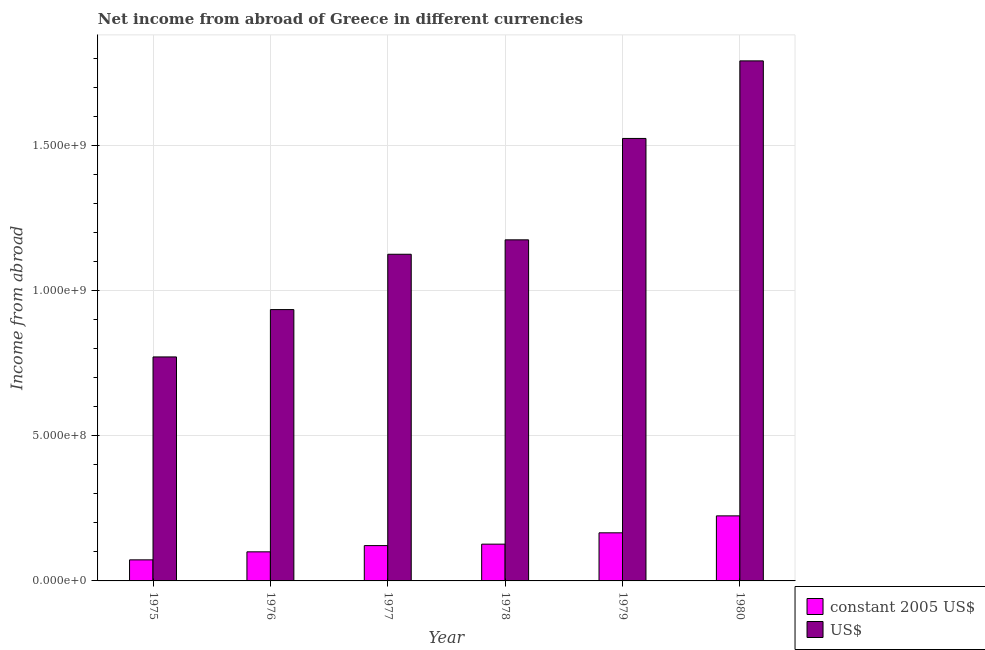Are the number of bars per tick equal to the number of legend labels?
Offer a terse response. Yes. Are the number of bars on each tick of the X-axis equal?
Your answer should be compact. Yes. In how many cases, is the number of bars for a given year not equal to the number of legend labels?
Give a very brief answer. 0. What is the income from abroad in constant 2005 us$ in 1975?
Offer a terse response. 7.26e+07. Across all years, what is the maximum income from abroad in us$?
Provide a short and direct response. 1.79e+09. Across all years, what is the minimum income from abroad in us$?
Your response must be concise. 7.72e+08. In which year was the income from abroad in constant 2005 us$ maximum?
Your response must be concise. 1980. In which year was the income from abroad in us$ minimum?
Ensure brevity in your answer.  1975. What is the total income from abroad in us$ in the graph?
Ensure brevity in your answer.  7.33e+09. What is the difference between the income from abroad in us$ in 1975 and that in 1976?
Offer a very short reply. -1.63e+08. What is the difference between the income from abroad in us$ in 1979 and the income from abroad in constant 2005 us$ in 1980?
Provide a succinct answer. -2.67e+08. What is the average income from abroad in constant 2005 us$ per year?
Provide a succinct answer. 1.35e+08. In the year 1979, what is the difference between the income from abroad in us$ and income from abroad in constant 2005 us$?
Provide a short and direct response. 0. In how many years, is the income from abroad in us$ greater than 400000000 units?
Offer a terse response. 6. What is the ratio of the income from abroad in us$ in 1975 to that in 1977?
Provide a succinct answer. 0.69. Is the income from abroad in us$ in 1977 less than that in 1979?
Your response must be concise. Yes. Is the difference between the income from abroad in us$ in 1976 and 1978 greater than the difference between the income from abroad in constant 2005 us$ in 1976 and 1978?
Provide a succinct answer. No. What is the difference between the highest and the second highest income from abroad in constant 2005 us$?
Your answer should be very brief. 5.84e+07. What is the difference between the highest and the lowest income from abroad in us$?
Offer a terse response. 1.02e+09. Is the sum of the income from abroad in constant 2005 us$ in 1975 and 1980 greater than the maximum income from abroad in us$ across all years?
Provide a short and direct response. Yes. What does the 2nd bar from the left in 1978 represents?
Offer a very short reply. US$. What does the 1st bar from the right in 1976 represents?
Your response must be concise. US$. How many bars are there?
Provide a succinct answer. 12. Are all the bars in the graph horizontal?
Make the answer very short. No. How many years are there in the graph?
Offer a very short reply. 6. What is the difference between two consecutive major ticks on the Y-axis?
Keep it short and to the point. 5.00e+08. Does the graph contain grids?
Provide a short and direct response. Yes. How many legend labels are there?
Keep it short and to the point. 2. What is the title of the graph?
Offer a terse response. Net income from abroad of Greece in different currencies. Does "Non-resident workers" appear as one of the legend labels in the graph?
Your response must be concise. No. What is the label or title of the Y-axis?
Offer a terse response. Income from abroad. What is the Income from abroad of constant 2005 US$ in 1975?
Your answer should be very brief. 7.26e+07. What is the Income from abroad of US$ in 1975?
Provide a succinct answer. 7.72e+08. What is the Income from abroad in constant 2005 US$ in 1976?
Your answer should be very brief. 1.00e+08. What is the Income from abroad of US$ in 1976?
Keep it short and to the point. 9.35e+08. What is the Income from abroad in constant 2005 US$ in 1977?
Give a very brief answer. 1.22e+08. What is the Income from abroad of US$ in 1977?
Provide a succinct answer. 1.13e+09. What is the Income from abroad of constant 2005 US$ in 1978?
Give a very brief answer. 1.27e+08. What is the Income from abroad in US$ in 1978?
Ensure brevity in your answer.  1.18e+09. What is the Income from abroad of constant 2005 US$ in 1979?
Make the answer very short. 1.66e+08. What is the Income from abroad in US$ in 1979?
Give a very brief answer. 1.52e+09. What is the Income from abroad in constant 2005 US$ in 1980?
Your answer should be very brief. 2.24e+08. What is the Income from abroad in US$ in 1980?
Offer a very short reply. 1.79e+09. Across all years, what is the maximum Income from abroad of constant 2005 US$?
Offer a very short reply. 2.24e+08. Across all years, what is the maximum Income from abroad in US$?
Your answer should be very brief. 1.79e+09. Across all years, what is the minimum Income from abroad of constant 2005 US$?
Provide a succinct answer. 7.26e+07. Across all years, what is the minimum Income from abroad of US$?
Provide a succinct answer. 7.72e+08. What is the total Income from abroad of constant 2005 US$ in the graph?
Offer a very short reply. 8.11e+08. What is the total Income from abroad of US$ in the graph?
Make the answer very short. 7.33e+09. What is the difference between the Income from abroad in constant 2005 US$ in 1975 and that in 1976?
Your answer should be very brief. -2.76e+07. What is the difference between the Income from abroad in US$ in 1975 and that in 1976?
Your answer should be compact. -1.63e+08. What is the difference between the Income from abroad in constant 2005 US$ in 1975 and that in 1977?
Your response must be concise. -4.91e+07. What is the difference between the Income from abroad in US$ in 1975 and that in 1977?
Offer a terse response. -3.54e+08. What is the difference between the Income from abroad in constant 2005 US$ in 1975 and that in 1978?
Provide a succinct answer. -5.41e+07. What is the difference between the Income from abroad of US$ in 1975 and that in 1978?
Provide a short and direct response. -4.04e+08. What is the difference between the Income from abroad of constant 2005 US$ in 1975 and that in 1979?
Provide a succinct answer. -9.31e+07. What is the difference between the Income from abroad in US$ in 1975 and that in 1979?
Make the answer very short. -7.53e+08. What is the difference between the Income from abroad in constant 2005 US$ in 1975 and that in 1980?
Offer a very short reply. -1.52e+08. What is the difference between the Income from abroad of US$ in 1975 and that in 1980?
Offer a very short reply. -1.02e+09. What is the difference between the Income from abroad of constant 2005 US$ in 1976 and that in 1977?
Keep it short and to the point. -2.15e+07. What is the difference between the Income from abroad of US$ in 1976 and that in 1977?
Offer a terse response. -1.91e+08. What is the difference between the Income from abroad in constant 2005 US$ in 1976 and that in 1978?
Provide a short and direct response. -2.65e+07. What is the difference between the Income from abroad in US$ in 1976 and that in 1978?
Provide a succinct answer. -2.40e+08. What is the difference between the Income from abroad in constant 2005 US$ in 1976 and that in 1979?
Provide a succinct answer. -6.55e+07. What is the difference between the Income from abroad in US$ in 1976 and that in 1979?
Provide a short and direct response. -5.90e+08. What is the difference between the Income from abroad in constant 2005 US$ in 1976 and that in 1980?
Make the answer very short. -1.24e+08. What is the difference between the Income from abroad of US$ in 1976 and that in 1980?
Your answer should be very brief. -8.57e+08. What is the difference between the Income from abroad of constant 2005 US$ in 1977 and that in 1978?
Your answer should be compact. -5.02e+06. What is the difference between the Income from abroad of US$ in 1977 and that in 1978?
Your answer should be compact. -4.97e+07. What is the difference between the Income from abroad in constant 2005 US$ in 1977 and that in 1979?
Offer a very short reply. -4.41e+07. What is the difference between the Income from abroad of US$ in 1977 and that in 1979?
Provide a short and direct response. -3.99e+08. What is the difference between the Income from abroad in constant 2005 US$ in 1977 and that in 1980?
Ensure brevity in your answer.  -1.03e+08. What is the difference between the Income from abroad of US$ in 1977 and that in 1980?
Your answer should be compact. -6.66e+08. What is the difference between the Income from abroad in constant 2005 US$ in 1978 and that in 1979?
Keep it short and to the point. -3.90e+07. What is the difference between the Income from abroad of US$ in 1978 and that in 1979?
Give a very brief answer. -3.49e+08. What is the difference between the Income from abroad of constant 2005 US$ in 1978 and that in 1980?
Provide a succinct answer. -9.75e+07. What is the difference between the Income from abroad of US$ in 1978 and that in 1980?
Keep it short and to the point. -6.17e+08. What is the difference between the Income from abroad in constant 2005 US$ in 1979 and that in 1980?
Your answer should be compact. -5.84e+07. What is the difference between the Income from abroad of US$ in 1979 and that in 1980?
Offer a very short reply. -2.67e+08. What is the difference between the Income from abroad in constant 2005 US$ in 1975 and the Income from abroad in US$ in 1976?
Give a very brief answer. -8.62e+08. What is the difference between the Income from abroad of constant 2005 US$ in 1975 and the Income from abroad of US$ in 1977?
Provide a short and direct response. -1.05e+09. What is the difference between the Income from abroad in constant 2005 US$ in 1975 and the Income from abroad in US$ in 1978?
Your response must be concise. -1.10e+09. What is the difference between the Income from abroad of constant 2005 US$ in 1975 and the Income from abroad of US$ in 1979?
Ensure brevity in your answer.  -1.45e+09. What is the difference between the Income from abroad of constant 2005 US$ in 1975 and the Income from abroad of US$ in 1980?
Provide a succinct answer. -1.72e+09. What is the difference between the Income from abroad of constant 2005 US$ in 1976 and the Income from abroad of US$ in 1977?
Your answer should be compact. -1.03e+09. What is the difference between the Income from abroad of constant 2005 US$ in 1976 and the Income from abroad of US$ in 1978?
Your answer should be very brief. -1.08e+09. What is the difference between the Income from abroad in constant 2005 US$ in 1976 and the Income from abroad in US$ in 1979?
Offer a very short reply. -1.42e+09. What is the difference between the Income from abroad of constant 2005 US$ in 1976 and the Income from abroad of US$ in 1980?
Keep it short and to the point. -1.69e+09. What is the difference between the Income from abroad in constant 2005 US$ in 1977 and the Income from abroad in US$ in 1978?
Keep it short and to the point. -1.05e+09. What is the difference between the Income from abroad of constant 2005 US$ in 1977 and the Income from abroad of US$ in 1979?
Provide a short and direct response. -1.40e+09. What is the difference between the Income from abroad in constant 2005 US$ in 1977 and the Income from abroad in US$ in 1980?
Your answer should be compact. -1.67e+09. What is the difference between the Income from abroad in constant 2005 US$ in 1978 and the Income from abroad in US$ in 1979?
Your response must be concise. -1.40e+09. What is the difference between the Income from abroad in constant 2005 US$ in 1978 and the Income from abroad in US$ in 1980?
Your response must be concise. -1.67e+09. What is the difference between the Income from abroad in constant 2005 US$ in 1979 and the Income from abroad in US$ in 1980?
Offer a terse response. -1.63e+09. What is the average Income from abroad in constant 2005 US$ per year?
Make the answer very short. 1.35e+08. What is the average Income from abroad in US$ per year?
Provide a short and direct response. 1.22e+09. In the year 1975, what is the difference between the Income from abroad of constant 2005 US$ and Income from abroad of US$?
Make the answer very short. -6.99e+08. In the year 1976, what is the difference between the Income from abroad of constant 2005 US$ and Income from abroad of US$?
Give a very brief answer. -8.35e+08. In the year 1977, what is the difference between the Income from abroad in constant 2005 US$ and Income from abroad in US$?
Your response must be concise. -1.00e+09. In the year 1978, what is the difference between the Income from abroad in constant 2005 US$ and Income from abroad in US$?
Provide a short and direct response. -1.05e+09. In the year 1979, what is the difference between the Income from abroad in constant 2005 US$ and Income from abroad in US$?
Make the answer very short. -1.36e+09. In the year 1980, what is the difference between the Income from abroad of constant 2005 US$ and Income from abroad of US$?
Make the answer very short. -1.57e+09. What is the ratio of the Income from abroad of constant 2005 US$ in 1975 to that in 1976?
Offer a very short reply. 0.72. What is the ratio of the Income from abroad of US$ in 1975 to that in 1976?
Your response must be concise. 0.83. What is the ratio of the Income from abroad of constant 2005 US$ in 1975 to that in 1977?
Offer a very short reply. 0.6. What is the ratio of the Income from abroad of US$ in 1975 to that in 1977?
Offer a terse response. 0.69. What is the ratio of the Income from abroad of constant 2005 US$ in 1975 to that in 1978?
Give a very brief answer. 0.57. What is the ratio of the Income from abroad in US$ in 1975 to that in 1978?
Keep it short and to the point. 0.66. What is the ratio of the Income from abroad of constant 2005 US$ in 1975 to that in 1979?
Give a very brief answer. 0.44. What is the ratio of the Income from abroad of US$ in 1975 to that in 1979?
Ensure brevity in your answer.  0.51. What is the ratio of the Income from abroad of constant 2005 US$ in 1975 to that in 1980?
Give a very brief answer. 0.32. What is the ratio of the Income from abroad in US$ in 1975 to that in 1980?
Your answer should be very brief. 0.43. What is the ratio of the Income from abroad in constant 2005 US$ in 1976 to that in 1977?
Ensure brevity in your answer.  0.82. What is the ratio of the Income from abroad of US$ in 1976 to that in 1977?
Provide a short and direct response. 0.83. What is the ratio of the Income from abroad in constant 2005 US$ in 1976 to that in 1978?
Keep it short and to the point. 0.79. What is the ratio of the Income from abroad in US$ in 1976 to that in 1978?
Make the answer very short. 0.8. What is the ratio of the Income from abroad of constant 2005 US$ in 1976 to that in 1979?
Offer a very short reply. 0.6. What is the ratio of the Income from abroad of US$ in 1976 to that in 1979?
Keep it short and to the point. 0.61. What is the ratio of the Income from abroad of constant 2005 US$ in 1976 to that in 1980?
Your answer should be compact. 0.45. What is the ratio of the Income from abroad in US$ in 1976 to that in 1980?
Offer a very short reply. 0.52. What is the ratio of the Income from abroad in constant 2005 US$ in 1977 to that in 1978?
Provide a short and direct response. 0.96. What is the ratio of the Income from abroad of US$ in 1977 to that in 1978?
Your answer should be compact. 0.96. What is the ratio of the Income from abroad in constant 2005 US$ in 1977 to that in 1979?
Ensure brevity in your answer.  0.73. What is the ratio of the Income from abroad of US$ in 1977 to that in 1979?
Ensure brevity in your answer.  0.74. What is the ratio of the Income from abroad in constant 2005 US$ in 1977 to that in 1980?
Provide a short and direct response. 0.54. What is the ratio of the Income from abroad of US$ in 1977 to that in 1980?
Keep it short and to the point. 0.63. What is the ratio of the Income from abroad in constant 2005 US$ in 1978 to that in 1979?
Keep it short and to the point. 0.76. What is the ratio of the Income from abroad of US$ in 1978 to that in 1979?
Ensure brevity in your answer.  0.77. What is the ratio of the Income from abroad of constant 2005 US$ in 1978 to that in 1980?
Your response must be concise. 0.57. What is the ratio of the Income from abroad of US$ in 1978 to that in 1980?
Your response must be concise. 0.66. What is the ratio of the Income from abroad of constant 2005 US$ in 1979 to that in 1980?
Offer a very short reply. 0.74. What is the ratio of the Income from abroad in US$ in 1979 to that in 1980?
Offer a terse response. 0.85. What is the difference between the highest and the second highest Income from abroad of constant 2005 US$?
Make the answer very short. 5.84e+07. What is the difference between the highest and the second highest Income from abroad in US$?
Your response must be concise. 2.67e+08. What is the difference between the highest and the lowest Income from abroad in constant 2005 US$?
Offer a terse response. 1.52e+08. What is the difference between the highest and the lowest Income from abroad in US$?
Provide a short and direct response. 1.02e+09. 